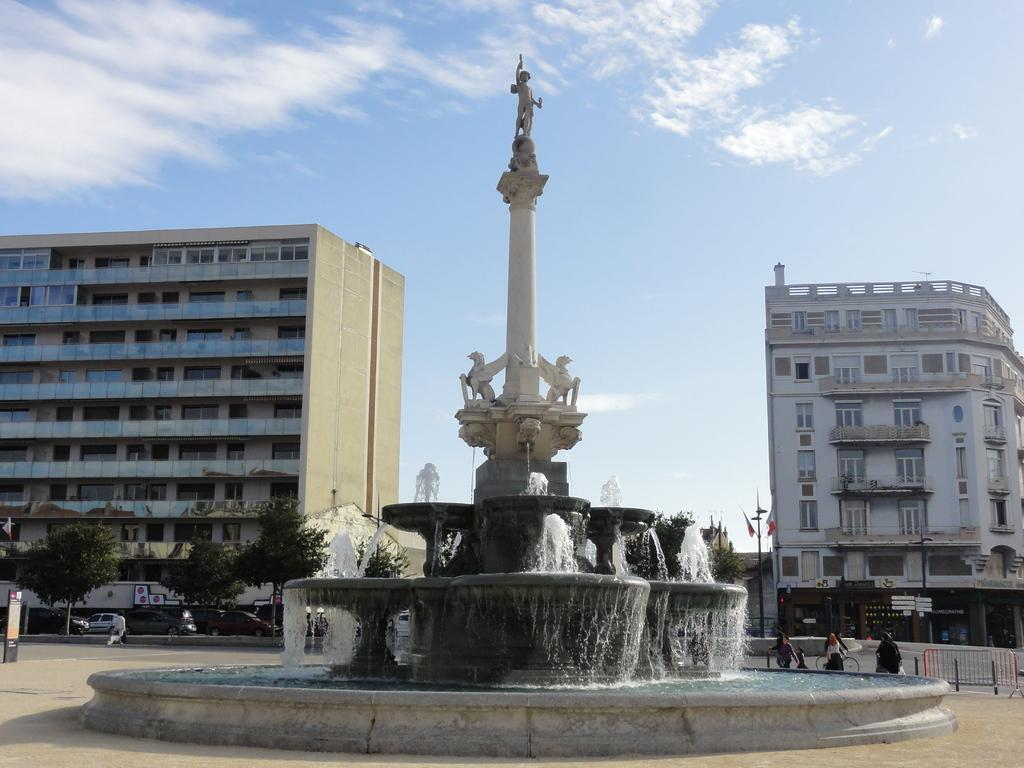What is the main subject in the middle of the image? There is a water fountain in the middle of the image. What other structures are present in the image? There is a pillar with statues in the image. What can be seen in the background of the image? There are people, buildings, vehicles, and the sky visible in the background of the image. What is the condition of the sky in the image? The sky is visible in the background of the image, and there are clouds present. What type of attraction can be seen in the alley in the image? There is no alley or attraction present in the image; it features a water fountain and a pillar with statues. How many arms does the statue on the pillar have in the image? The image does not provide enough detail to determine the number of arms on the statue; it only shows the pillar with statues. 